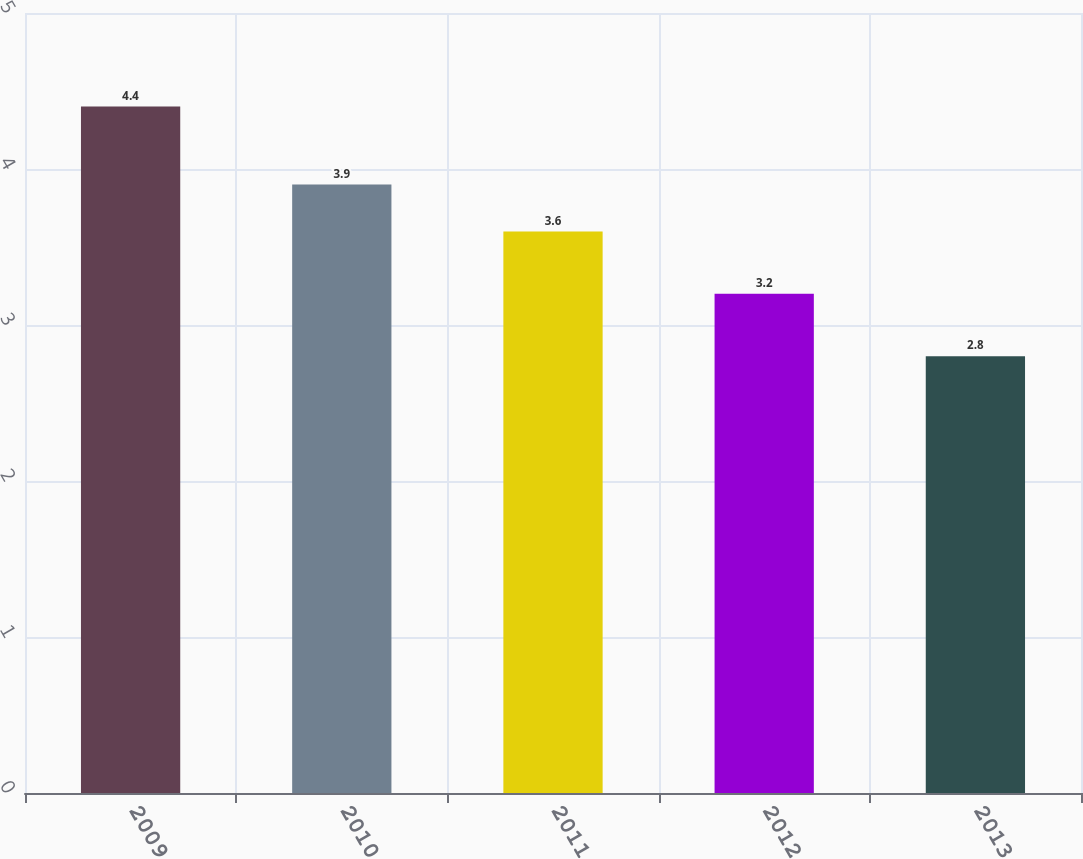Convert chart to OTSL. <chart><loc_0><loc_0><loc_500><loc_500><bar_chart><fcel>2009<fcel>2010<fcel>2011<fcel>2012<fcel>2013<nl><fcel>4.4<fcel>3.9<fcel>3.6<fcel>3.2<fcel>2.8<nl></chart> 